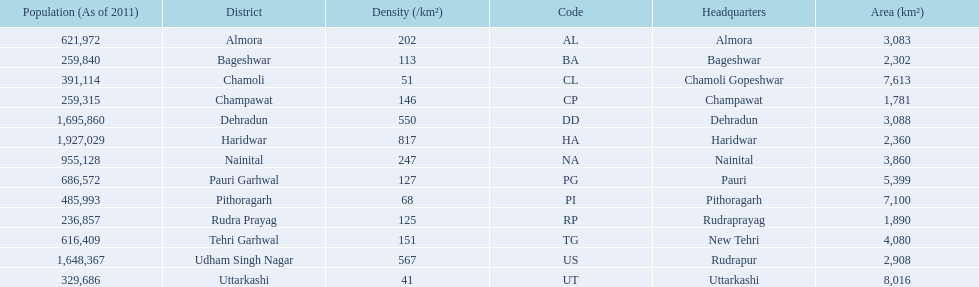Could you help me parse every detail presented in this table? {'header': ['Population (As of 2011)', 'District', 'Density (/km²)', 'Code', 'Headquarters', 'Area (km²)'], 'rows': [['621,972', 'Almora', '202', 'AL', 'Almora', '3,083'], ['259,840', 'Bageshwar', '113', 'BA', 'Bageshwar', '2,302'], ['391,114', 'Chamoli', '51', 'CL', 'Chamoli Gopeshwar', '7,613'], ['259,315', 'Champawat', '146', 'CP', 'Champawat', '1,781'], ['1,695,860', 'Dehradun', '550', 'DD', 'Dehradun', '3,088'], ['1,927,029', 'Haridwar', '817', 'HA', 'Haridwar', '2,360'], ['955,128', 'Nainital', '247', 'NA', 'Nainital', '3,860'], ['686,572', 'Pauri Garhwal', '127', 'PG', 'Pauri', '5,399'], ['485,993', 'Pithoragarh', '68', 'PI', 'Pithoragarh', '7,100'], ['236,857', 'Rudra Prayag', '125', 'RP', 'Rudraprayag', '1,890'], ['616,409', 'Tehri Garhwal', '151', 'TG', 'New Tehri', '4,080'], ['1,648,367', 'Udham Singh Nagar', '567', 'US', 'Rudrapur', '2,908'], ['329,686', 'Uttarkashi', '41', 'UT', 'Uttarkashi', '8,016']]} If a person was headquartered in almora what would be his/her district? Almora. 